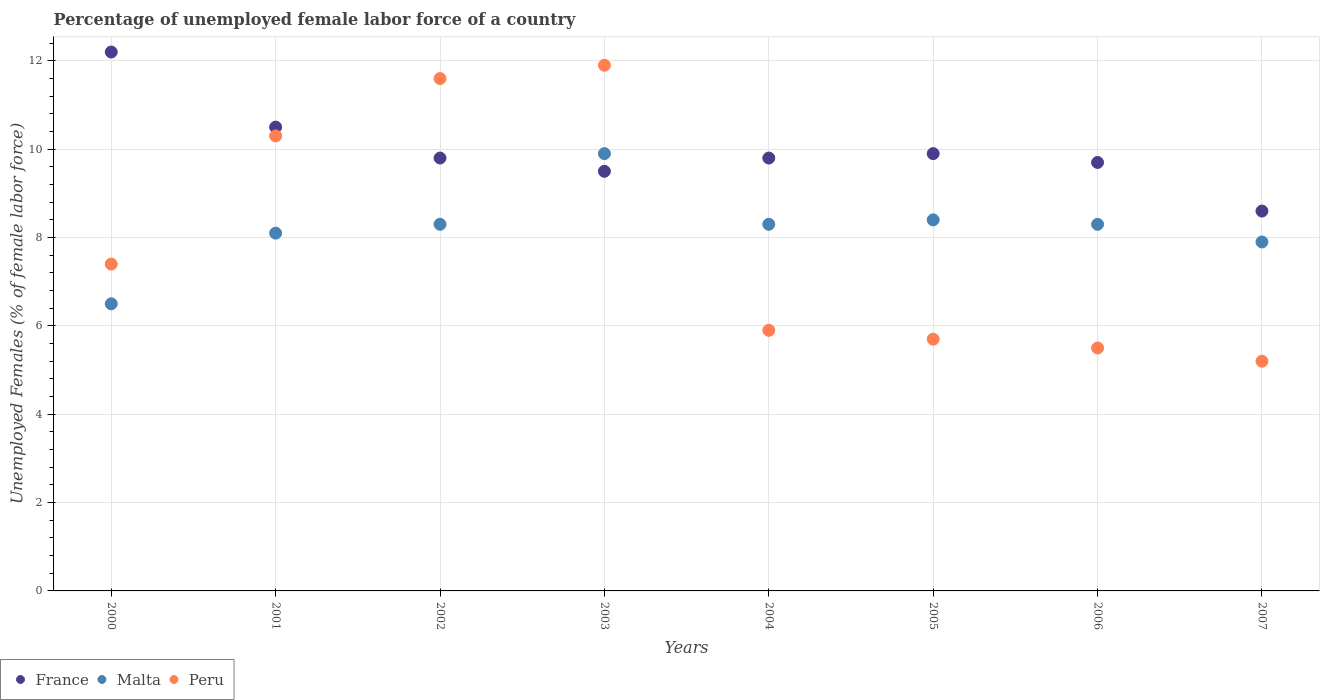What is the percentage of unemployed female labor force in Malta in 2004?
Your answer should be compact. 8.3. Across all years, what is the maximum percentage of unemployed female labor force in Peru?
Your answer should be very brief. 11.9. Across all years, what is the minimum percentage of unemployed female labor force in Peru?
Your answer should be compact. 5.2. What is the total percentage of unemployed female labor force in Malta in the graph?
Provide a short and direct response. 65.7. What is the difference between the percentage of unemployed female labor force in Peru in 2005 and that in 2007?
Your response must be concise. 0.5. What is the difference between the percentage of unemployed female labor force in France in 2005 and the percentage of unemployed female labor force in Malta in 2007?
Keep it short and to the point. 2. What is the average percentage of unemployed female labor force in France per year?
Give a very brief answer. 10. In the year 2007, what is the difference between the percentage of unemployed female labor force in Malta and percentage of unemployed female labor force in Peru?
Offer a terse response. 2.7. What is the ratio of the percentage of unemployed female labor force in Malta in 2003 to that in 2006?
Your answer should be compact. 1.19. Is the percentage of unemployed female labor force in Peru in 2000 less than that in 2003?
Ensure brevity in your answer.  Yes. Is the difference between the percentage of unemployed female labor force in Malta in 2001 and 2005 greater than the difference between the percentage of unemployed female labor force in Peru in 2001 and 2005?
Your response must be concise. No. What is the difference between the highest and the lowest percentage of unemployed female labor force in Malta?
Offer a terse response. 3.4. In how many years, is the percentage of unemployed female labor force in Peru greater than the average percentage of unemployed female labor force in Peru taken over all years?
Offer a terse response. 3. Does the percentage of unemployed female labor force in France monotonically increase over the years?
Offer a terse response. No. How many dotlines are there?
Your response must be concise. 3. Are the values on the major ticks of Y-axis written in scientific E-notation?
Provide a short and direct response. No. Does the graph contain any zero values?
Offer a terse response. No. What is the title of the graph?
Offer a terse response. Percentage of unemployed female labor force of a country. What is the label or title of the Y-axis?
Ensure brevity in your answer.  Unemployed Females (% of female labor force). What is the Unemployed Females (% of female labor force) in France in 2000?
Make the answer very short. 12.2. What is the Unemployed Females (% of female labor force) of Peru in 2000?
Offer a very short reply. 7.4. What is the Unemployed Females (% of female labor force) of France in 2001?
Give a very brief answer. 10.5. What is the Unemployed Females (% of female labor force) in Malta in 2001?
Provide a succinct answer. 8.1. What is the Unemployed Females (% of female labor force) in Peru in 2001?
Your response must be concise. 10.3. What is the Unemployed Females (% of female labor force) in France in 2002?
Ensure brevity in your answer.  9.8. What is the Unemployed Females (% of female labor force) in Malta in 2002?
Provide a short and direct response. 8.3. What is the Unemployed Females (% of female labor force) in Peru in 2002?
Your response must be concise. 11.6. What is the Unemployed Females (% of female labor force) in Malta in 2003?
Your response must be concise. 9.9. What is the Unemployed Females (% of female labor force) of Peru in 2003?
Offer a terse response. 11.9. What is the Unemployed Females (% of female labor force) in France in 2004?
Provide a short and direct response. 9.8. What is the Unemployed Females (% of female labor force) of Malta in 2004?
Ensure brevity in your answer.  8.3. What is the Unemployed Females (% of female labor force) of Peru in 2004?
Your answer should be very brief. 5.9. What is the Unemployed Females (% of female labor force) in France in 2005?
Offer a very short reply. 9.9. What is the Unemployed Females (% of female labor force) of Malta in 2005?
Give a very brief answer. 8.4. What is the Unemployed Females (% of female labor force) of Peru in 2005?
Provide a short and direct response. 5.7. What is the Unemployed Females (% of female labor force) in France in 2006?
Make the answer very short. 9.7. What is the Unemployed Females (% of female labor force) of Malta in 2006?
Make the answer very short. 8.3. What is the Unemployed Females (% of female labor force) in France in 2007?
Ensure brevity in your answer.  8.6. What is the Unemployed Females (% of female labor force) of Malta in 2007?
Provide a succinct answer. 7.9. What is the Unemployed Females (% of female labor force) in Peru in 2007?
Provide a short and direct response. 5.2. Across all years, what is the maximum Unemployed Females (% of female labor force) in France?
Your answer should be very brief. 12.2. Across all years, what is the maximum Unemployed Females (% of female labor force) in Malta?
Provide a short and direct response. 9.9. Across all years, what is the maximum Unemployed Females (% of female labor force) of Peru?
Provide a succinct answer. 11.9. Across all years, what is the minimum Unemployed Females (% of female labor force) in France?
Your answer should be very brief. 8.6. Across all years, what is the minimum Unemployed Females (% of female labor force) of Peru?
Your answer should be very brief. 5.2. What is the total Unemployed Females (% of female labor force) in Malta in the graph?
Ensure brevity in your answer.  65.7. What is the total Unemployed Females (% of female labor force) in Peru in the graph?
Provide a succinct answer. 63.5. What is the difference between the Unemployed Females (% of female labor force) of France in 2000 and that in 2001?
Keep it short and to the point. 1.7. What is the difference between the Unemployed Females (% of female labor force) of France in 2000 and that in 2002?
Ensure brevity in your answer.  2.4. What is the difference between the Unemployed Females (% of female labor force) in Malta in 2000 and that in 2002?
Give a very brief answer. -1.8. What is the difference between the Unemployed Females (% of female labor force) in Peru in 2000 and that in 2002?
Your answer should be very brief. -4.2. What is the difference between the Unemployed Females (% of female labor force) of France in 2000 and that in 2003?
Your answer should be very brief. 2.7. What is the difference between the Unemployed Females (% of female labor force) of Malta in 2000 and that in 2003?
Your response must be concise. -3.4. What is the difference between the Unemployed Females (% of female labor force) of Peru in 2000 and that in 2003?
Your answer should be compact. -4.5. What is the difference between the Unemployed Females (% of female labor force) in Peru in 2000 and that in 2004?
Offer a very short reply. 1.5. What is the difference between the Unemployed Females (% of female labor force) of Malta in 2000 and that in 2005?
Offer a very short reply. -1.9. What is the difference between the Unemployed Females (% of female labor force) of Peru in 2000 and that in 2005?
Make the answer very short. 1.7. What is the difference between the Unemployed Females (% of female labor force) of Malta in 2000 and that in 2006?
Keep it short and to the point. -1.8. What is the difference between the Unemployed Females (% of female labor force) in Peru in 2000 and that in 2006?
Make the answer very short. 1.9. What is the difference between the Unemployed Females (% of female labor force) in France in 2000 and that in 2007?
Your answer should be very brief. 3.6. What is the difference between the Unemployed Females (% of female labor force) in Malta in 2000 and that in 2007?
Ensure brevity in your answer.  -1.4. What is the difference between the Unemployed Females (% of female labor force) of Peru in 2000 and that in 2007?
Your answer should be compact. 2.2. What is the difference between the Unemployed Females (% of female labor force) in France in 2001 and that in 2002?
Provide a succinct answer. 0.7. What is the difference between the Unemployed Females (% of female labor force) of Malta in 2001 and that in 2002?
Make the answer very short. -0.2. What is the difference between the Unemployed Females (% of female labor force) of Peru in 2001 and that in 2002?
Your answer should be very brief. -1.3. What is the difference between the Unemployed Females (% of female labor force) of France in 2001 and that in 2003?
Make the answer very short. 1. What is the difference between the Unemployed Females (% of female labor force) in Malta in 2001 and that in 2003?
Your response must be concise. -1.8. What is the difference between the Unemployed Females (% of female labor force) of Malta in 2001 and that in 2004?
Provide a succinct answer. -0.2. What is the difference between the Unemployed Females (% of female labor force) of France in 2001 and that in 2005?
Your answer should be very brief. 0.6. What is the difference between the Unemployed Females (% of female labor force) of Malta in 2001 and that in 2006?
Your response must be concise. -0.2. What is the difference between the Unemployed Females (% of female labor force) of France in 2001 and that in 2007?
Your answer should be very brief. 1.9. What is the difference between the Unemployed Females (% of female labor force) in Peru in 2001 and that in 2007?
Offer a very short reply. 5.1. What is the difference between the Unemployed Females (% of female labor force) in France in 2002 and that in 2004?
Your response must be concise. 0. What is the difference between the Unemployed Females (% of female labor force) of Peru in 2002 and that in 2004?
Make the answer very short. 5.7. What is the difference between the Unemployed Females (% of female labor force) of France in 2002 and that in 2006?
Your answer should be compact. 0.1. What is the difference between the Unemployed Females (% of female labor force) in Malta in 2002 and that in 2006?
Your answer should be compact. 0. What is the difference between the Unemployed Females (% of female labor force) of Peru in 2002 and that in 2006?
Your answer should be compact. 6.1. What is the difference between the Unemployed Females (% of female labor force) of France in 2002 and that in 2007?
Offer a terse response. 1.2. What is the difference between the Unemployed Females (% of female labor force) in Peru in 2002 and that in 2007?
Your response must be concise. 6.4. What is the difference between the Unemployed Females (% of female labor force) of Malta in 2003 and that in 2004?
Your answer should be compact. 1.6. What is the difference between the Unemployed Females (% of female labor force) in France in 2003 and that in 2005?
Offer a very short reply. -0.4. What is the difference between the Unemployed Females (% of female labor force) of Malta in 2003 and that in 2005?
Make the answer very short. 1.5. What is the difference between the Unemployed Females (% of female labor force) of Malta in 2003 and that in 2006?
Ensure brevity in your answer.  1.6. What is the difference between the Unemployed Females (% of female labor force) in France in 2003 and that in 2007?
Keep it short and to the point. 0.9. What is the difference between the Unemployed Females (% of female labor force) of Malta in 2003 and that in 2007?
Give a very brief answer. 2. What is the difference between the Unemployed Females (% of female labor force) in France in 2004 and that in 2005?
Give a very brief answer. -0.1. What is the difference between the Unemployed Females (% of female labor force) in Malta in 2004 and that in 2005?
Offer a very short reply. -0.1. What is the difference between the Unemployed Females (% of female labor force) in Peru in 2004 and that in 2005?
Offer a very short reply. 0.2. What is the difference between the Unemployed Females (% of female labor force) in France in 2005 and that in 2006?
Ensure brevity in your answer.  0.2. What is the difference between the Unemployed Females (% of female labor force) in Malta in 2005 and that in 2007?
Offer a terse response. 0.5. What is the difference between the Unemployed Females (% of female labor force) of France in 2006 and that in 2007?
Provide a succinct answer. 1.1. What is the difference between the Unemployed Females (% of female labor force) of Malta in 2006 and that in 2007?
Ensure brevity in your answer.  0.4. What is the difference between the Unemployed Females (% of female labor force) in France in 2000 and the Unemployed Females (% of female labor force) in Peru in 2001?
Offer a very short reply. 1.9. What is the difference between the Unemployed Females (% of female labor force) of France in 2000 and the Unemployed Females (% of female labor force) of Malta in 2002?
Your answer should be very brief. 3.9. What is the difference between the Unemployed Females (% of female labor force) of France in 2000 and the Unemployed Females (% of female labor force) of Peru in 2002?
Offer a terse response. 0.6. What is the difference between the Unemployed Females (% of female labor force) in France in 2000 and the Unemployed Females (% of female labor force) in Malta in 2003?
Offer a very short reply. 2.3. What is the difference between the Unemployed Females (% of female labor force) of France in 2000 and the Unemployed Females (% of female labor force) of Malta in 2004?
Ensure brevity in your answer.  3.9. What is the difference between the Unemployed Females (% of female labor force) in France in 2000 and the Unemployed Females (% of female labor force) in Peru in 2005?
Make the answer very short. 6.5. What is the difference between the Unemployed Females (% of female labor force) of Malta in 2000 and the Unemployed Females (% of female labor force) of Peru in 2005?
Your answer should be very brief. 0.8. What is the difference between the Unemployed Females (% of female labor force) of France in 2000 and the Unemployed Females (% of female labor force) of Malta in 2006?
Your answer should be compact. 3.9. What is the difference between the Unemployed Females (% of female labor force) of Malta in 2000 and the Unemployed Females (% of female labor force) of Peru in 2006?
Offer a terse response. 1. What is the difference between the Unemployed Females (% of female labor force) in France in 2000 and the Unemployed Females (% of female labor force) in Peru in 2007?
Provide a succinct answer. 7. What is the difference between the Unemployed Females (% of female labor force) in Malta in 2000 and the Unemployed Females (% of female labor force) in Peru in 2007?
Your response must be concise. 1.3. What is the difference between the Unemployed Females (% of female labor force) of France in 2001 and the Unemployed Females (% of female labor force) of Peru in 2002?
Your response must be concise. -1.1. What is the difference between the Unemployed Females (% of female labor force) in France in 2001 and the Unemployed Females (% of female labor force) in Malta in 2003?
Offer a very short reply. 0.6. What is the difference between the Unemployed Females (% of female labor force) in France in 2001 and the Unemployed Females (% of female labor force) in Peru in 2003?
Your response must be concise. -1.4. What is the difference between the Unemployed Females (% of female labor force) in Malta in 2001 and the Unemployed Females (% of female labor force) in Peru in 2004?
Your answer should be compact. 2.2. What is the difference between the Unemployed Females (% of female labor force) in France in 2001 and the Unemployed Females (% of female labor force) in Peru in 2005?
Ensure brevity in your answer.  4.8. What is the difference between the Unemployed Females (% of female labor force) in France in 2001 and the Unemployed Females (% of female labor force) in Malta in 2006?
Provide a succinct answer. 2.2. What is the difference between the Unemployed Females (% of female labor force) in France in 2001 and the Unemployed Females (% of female labor force) in Malta in 2007?
Ensure brevity in your answer.  2.6. What is the difference between the Unemployed Females (% of female labor force) of France in 2001 and the Unemployed Females (% of female labor force) of Peru in 2007?
Your response must be concise. 5.3. What is the difference between the Unemployed Females (% of female labor force) of Malta in 2001 and the Unemployed Females (% of female labor force) of Peru in 2007?
Your answer should be compact. 2.9. What is the difference between the Unemployed Females (% of female labor force) in Malta in 2002 and the Unemployed Females (% of female labor force) in Peru in 2004?
Provide a short and direct response. 2.4. What is the difference between the Unemployed Females (% of female labor force) in Malta in 2002 and the Unemployed Females (% of female labor force) in Peru in 2005?
Make the answer very short. 2.6. What is the difference between the Unemployed Females (% of female labor force) of Malta in 2002 and the Unemployed Females (% of female labor force) of Peru in 2006?
Provide a succinct answer. 2.8. What is the difference between the Unemployed Females (% of female labor force) of France in 2003 and the Unemployed Females (% of female labor force) of Malta in 2004?
Provide a short and direct response. 1.2. What is the difference between the Unemployed Females (% of female labor force) of France in 2003 and the Unemployed Females (% of female labor force) of Peru in 2005?
Your response must be concise. 3.8. What is the difference between the Unemployed Females (% of female labor force) in Malta in 2003 and the Unemployed Females (% of female labor force) in Peru in 2005?
Offer a very short reply. 4.2. What is the difference between the Unemployed Females (% of female labor force) in France in 2003 and the Unemployed Females (% of female labor force) in Malta in 2006?
Ensure brevity in your answer.  1.2. What is the difference between the Unemployed Females (% of female labor force) of France in 2003 and the Unemployed Females (% of female labor force) of Peru in 2006?
Give a very brief answer. 4. What is the difference between the Unemployed Females (% of female labor force) of Malta in 2003 and the Unemployed Females (% of female labor force) of Peru in 2006?
Your response must be concise. 4.4. What is the difference between the Unemployed Females (% of female labor force) of France in 2003 and the Unemployed Females (% of female labor force) of Peru in 2007?
Give a very brief answer. 4.3. What is the difference between the Unemployed Females (% of female labor force) in France in 2004 and the Unemployed Females (% of female labor force) in Malta in 2005?
Give a very brief answer. 1.4. What is the difference between the Unemployed Females (% of female labor force) of France in 2004 and the Unemployed Females (% of female labor force) of Peru in 2006?
Your answer should be compact. 4.3. What is the difference between the Unemployed Females (% of female labor force) of Malta in 2004 and the Unemployed Females (% of female labor force) of Peru in 2006?
Your answer should be compact. 2.8. What is the difference between the Unemployed Females (% of female labor force) in France in 2004 and the Unemployed Females (% of female labor force) in Malta in 2007?
Provide a succinct answer. 1.9. What is the difference between the Unemployed Females (% of female labor force) in France in 2004 and the Unemployed Females (% of female labor force) in Peru in 2007?
Offer a terse response. 4.6. What is the difference between the Unemployed Females (% of female labor force) of France in 2006 and the Unemployed Females (% of female labor force) of Malta in 2007?
Provide a short and direct response. 1.8. What is the average Unemployed Females (% of female labor force) in France per year?
Offer a very short reply. 10. What is the average Unemployed Females (% of female labor force) in Malta per year?
Your response must be concise. 8.21. What is the average Unemployed Females (% of female labor force) in Peru per year?
Your response must be concise. 7.94. In the year 2000, what is the difference between the Unemployed Females (% of female labor force) in Malta and Unemployed Females (% of female labor force) in Peru?
Keep it short and to the point. -0.9. In the year 2001, what is the difference between the Unemployed Females (% of female labor force) of France and Unemployed Females (% of female labor force) of Peru?
Offer a terse response. 0.2. In the year 2001, what is the difference between the Unemployed Females (% of female labor force) in Malta and Unemployed Females (% of female labor force) in Peru?
Provide a short and direct response. -2.2. In the year 2002, what is the difference between the Unemployed Females (% of female labor force) in France and Unemployed Females (% of female labor force) in Malta?
Give a very brief answer. 1.5. In the year 2002, what is the difference between the Unemployed Females (% of female labor force) in France and Unemployed Females (% of female labor force) in Peru?
Make the answer very short. -1.8. In the year 2003, what is the difference between the Unemployed Females (% of female labor force) of France and Unemployed Females (% of female labor force) of Peru?
Ensure brevity in your answer.  -2.4. In the year 2004, what is the difference between the Unemployed Females (% of female labor force) in France and Unemployed Females (% of female labor force) in Malta?
Your answer should be compact. 1.5. In the year 2004, what is the difference between the Unemployed Females (% of female labor force) in France and Unemployed Females (% of female labor force) in Peru?
Your answer should be very brief. 3.9. In the year 2005, what is the difference between the Unemployed Females (% of female labor force) of France and Unemployed Females (% of female labor force) of Malta?
Provide a succinct answer. 1.5. In the year 2006, what is the difference between the Unemployed Females (% of female labor force) in France and Unemployed Females (% of female labor force) in Malta?
Your answer should be very brief. 1.4. In the year 2006, what is the difference between the Unemployed Females (% of female labor force) in Malta and Unemployed Females (% of female labor force) in Peru?
Ensure brevity in your answer.  2.8. In the year 2007, what is the difference between the Unemployed Females (% of female labor force) of Malta and Unemployed Females (% of female labor force) of Peru?
Make the answer very short. 2.7. What is the ratio of the Unemployed Females (% of female labor force) in France in 2000 to that in 2001?
Offer a terse response. 1.16. What is the ratio of the Unemployed Females (% of female labor force) of Malta in 2000 to that in 2001?
Your answer should be compact. 0.8. What is the ratio of the Unemployed Females (% of female labor force) in Peru in 2000 to that in 2001?
Your answer should be compact. 0.72. What is the ratio of the Unemployed Females (% of female labor force) of France in 2000 to that in 2002?
Give a very brief answer. 1.24. What is the ratio of the Unemployed Females (% of female labor force) of Malta in 2000 to that in 2002?
Give a very brief answer. 0.78. What is the ratio of the Unemployed Females (% of female labor force) of Peru in 2000 to that in 2002?
Your response must be concise. 0.64. What is the ratio of the Unemployed Females (% of female labor force) in France in 2000 to that in 2003?
Provide a succinct answer. 1.28. What is the ratio of the Unemployed Females (% of female labor force) in Malta in 2000 to that in 2003?
Provide a succinct answer. 0.66. What is the ratio of the Unemployed Females (% of female labor force) of Peru in 2000 to that in 2003?
Keep it short and to the point. 0.62. What is the ratio of the Unemployed Females (% of female labor force) of France in 2000 to that in 2004?
Ensure brevity in your answer.  1.24. What is the ratio of the Unemployed Females (% of female labor force) of Malta in 2000 to that in 2004?
Give a very brief answer. 0.78. What is the ratio of the Unemployed Females (% of female labor force) in Peru in 2000 to that in 2004?
Offer a very short reply. 1.25. What is the ratio of the Unemployed Females (% of female labor force) in France in 2000 to that in 2005?
Provide a succinct answer. 1.23. What is the ratio of the Unemployed Females (% of female labor force) of Malta in 2000 to that in 2005?
Make the answer very short. 0.77. What is the ratio of the Unemployed Females (% of female labor force) of Peru in 2000 to that in 2005?
Your response must be concise. 1.3. What is the ratio of the Unemployed Females (% of female labor force) in France in 2000 to that in 2006?
Make the answer very short. 1.26. What is the ratio of the Unemployed Females (% of female labor force) of Malta in 2000 to that in 2006?
Keep it short and to the point. 0.78. What is the ratio of the Unemployed Females (% of female labor force) in Peru in 2000 to that in 2006?
Keep it short and to the point. 1.35. What is the ratio of the Unemployed Females (% of female labor force) in France in 2000 to that in 2007?
Provide a succinct answer. 1.42. What is the ratio of the Unemployed Females (% of female labor force) of Malta in 2000 to that in 2007?
Keep it short and to the point. 0.82. What is the ratio of the Unemployed Females (% of female labor force) of Peru in 2000 to that in 2007?
Provide a succinct answer. 1.42. What is the ratio of the Unemployed Females (% of female labor force) of France in 2001 to that in 2002?
Provide a short and direct response. 1.07. What is the ratio of the Unemployed Females (% of female labor force) of Malta in 2001 to that in 2002?
Keep it short and to the point. 0.98. What is the ratio of the Unemployed Females (% of female labor force) of Peru in 2001 to that in 2002?
Offer a very short reply. 0.89. What is the ratio of the Unemployed Females (% of female labor force) in France in 2001 to that in 2003?
Your response must be concise. 1.11. What is the ratio of the Unemployed Females (% of female labor force) of Malta in 2001 to that in 2003?
Your answer should be compact. 0.82. What is the ratio of the Unemployed Females (% of female labor force) in Peru in 2001 to that in 2003?
Your answer should be very brief. 0.87. What is the ratio of the Unemployed Females (% of female labor force) of France in 2001 to that in 2004?
Your response must be concise. 1.07. What is the ratio of the Unemployed Females (% of female labor force) of Malta in 2001 to that in 2004?
Your response must be concise. 0.98. What is the ratio of the Unemployed Females (% of female labor force) in Peru in 2001 to that in 2004?
Your answer should be very brief. 1.75. What is the ratio of the Unemployed Females (% of female labor force) of France in 2001 to that in 2005?
Provide a succinct answer. 1.06. What is the ratio of the Unemployed Females (% of female labor force) in Malta in 2001 to that in 2005?
Ensure brevity in your answer.  0.96. What is the ratio of the Unemployed Females (% of female labor force) in Peru in 2001 to that in 2005?
Make the answer very short. 1.81. What is the ratio of the Unemployed Females (% of female labor force) of France in 2001 to that in 2006?
Provide a short and direct response. 1.08. What is the ratio of the Unemployed Females (% of female labor force) of Malta in 2001 to that in 2006?
Your answer should be compact. 0.98. What is the ratio of the Unemployed Females (% of female labor force) of Peru in 2001 to that in 2006?
Provide a short and direct response. 1.87. What is the ratio of the Unemployed Females (% of female labor force) of France in 2001 to that in 2007?
Ensure brevity in your answer.  1.22. What is the ratio of the Unemployed Females (% of female labor force) in Malta in 2001 to that in 2007?
Provide a succinct answer. 1.03. What is the ratio of the Unemployed Females (% of female labor force) in Peru in 2001 to that in 2007?
Offer a terse response. 1.98. What is the ratio of the Unemployed Females (% of female labor force) of France in 2002 to that in 2003?
Provide a succinct answer. 1.03. What is the ratio of the Unemployed Females (% of female labor force) in Malta in 2002 to that in 2003?
Offer a terse response. 0.84. What is the ratio of the Unemployed Females (% of female labor force) of Peru in 2002 to that in 2003?
Provide a short and direct response. 0.97. What is the ratio of the Unemployed Females (% of female labor force) of France in 2002 to that in 2004?
Offer a very short reply. 1. What is the ratio of the Unemployed Females (% of female labor force) of Peru in 2002 to that in 2004?
Your answer should be compact. 1.97. What is the ratio of the Unemployed Females (% of female labor force) in France in 2002 to that in 2005?
Make the answer very short. 0.99. What is the ratio of the Unemployed Females (% of female labor force) of Malta in 2002 to that in 2005?
Your answer should be compact. 0.99. What is the ratio of the Unemployed Females (% of female labor force) in Peru in 2002 to that in 2005?
Offer a very short reply. 2.04. What is the ratio of the Unemployed Females (% of female labor force) in France in 2002 to that in 2006?
Ensure brevity in your answer.  1.01. What is the ratio of the Unemployed Females (% of female labor force) in Malta in 2002 to that in 2006?
Make the answer very short. 1. What is the ratio of the Unemployed Females (% of female labor force) in Peru in 2002 to that in 2006?
Provide a succinct answer. 2.11. What is the ratio of the Unemployed Females (% of female labor force) of France in 2002 to that in 2007?
Give a very brief answer. 1.14. What is the ratio of the Unemployed Females (% of female labor force) of Malta in 2002 to that in 2007?
Your answer should be compact. 1.05. What is the ratio of the Unemployed Females (% of female labor force) in Peru in 2002 to that in 2007?
Your answer should be very brief. 2.23. What is the ratio of the Unemployed Females (% of female labor force) of France in 2003 to that in 2004?
Ensure brevity in your answer.  0.97. What is the ratio of the Unemployed Females (% of female labor force) in Malta in 2003 to that in 2004?
Make the answer very short. 1.19. What is the ratio of the Unemployed Females (% of female labor force) of Peru in 2003 to that in 2004?
Provide a succinct answer. 2.02. What is the ratio of the Unemployed Females (% of female labor force) in France in 2003 to that in 2005?
Your answer should be very brief. 0.96. What is the ratio of the Unemployed Females (% of female labor force) in Malta in 2003 to that in 2005?
Offer a very short reply. 1.18. What is the ratio of the Unemployed Females (% of female labor force) of Peru in 2003 to that in 2005?
Your answer should be compact. 2.09. What is the ratio of the Unemployed Females (% of female labor force) in France in 2003 to that in 2006?
Your response must be concise. 0.98. What is the ratio of the Unemployed Females (% of female labor force) of Malta in 2003 to that in 2006?
Your response must be concise. 1.19. What is the ratio of the Unemployed Females (% of female labor force) of Peru in 2003 to that in 2006?
Offer a very short reply. 2.16. What is the ratio of the Unemployed Females (% of female labor force) in France in 2003 to that in 2007?
Your answer should be very brief. 1.1. What is the ratio of the Unemployed Females (% of female labor force) in Malta in 2003 to that in 2007?
Keep it short and to the point. 1.25. What is the ratio of the Unemployed Females (% of female labor force) of Peru in 2003 to that in 2007?
Provide a short and direct response. 2.29. What is the ratio of the Unemployed Females (% of female labor force) in Peru in 2004 to that in 2005?
Offer a very short reply. 1.04. What is the ratio of the Unemployed Females (% of female labor force) in France in 2004 to that in 2006?
Provide a short and direct response. 1.01. What is the ratio of the Unemployed Females (% of female labor force) in Malta in 2004 to that in 2006?
Provide a short and direct response. 1. What is the ratio of the Unemployed Females (% of female labor force) of Peru in 2004 to that in 2006?
Provide a short and direct response. 1.07. What is the ratio of the Unemployed Females (% of female labor force) in France in 2004 to that in 2007?
Keep it short and to the point. 1.14. What is the ratio of the Unemployed Females (% of female labor force) of Malta in 2004 to that in 2007?
Provide a short and direct response. 1.05. What is the ratio of the Unemployed Females (% of female labor force) in Peru in 2004 to that in 2007?
Provide a short and direct response. 1.13. What is the ratio of the Unemployed Females (% of female labor force) of France in 2005 to that in 2006?
Make the answer very short. 1.02. What is the ratio of the Unemployed Females (% of female labor force) of Malta in 2005 to that in 2006?
Provide a succinct answer. 1.01. What is the ratio of the Unemployed Females (% of female labor force) of Peru in 2005 to that in 2006?
Keep it short and to the point. 1.04. What is the ratio of the Unemployed Females (% of female labor force) of France in 2005 to that in 2007?
Offer a terse response. 1.15. What is the ratio of the Unemployed Females (% of female labor force) of Malta in 2005 to that in 2007?
Your answer should be very brief. 1.06. What is the ratio of the Unemployed Females (% of female labor force) of Peru in 2005 to that in 2007?
Your answer should be compact. 1.1. What is the ratio of the Unemployed Females (% of female labor force) in France in 2006 to that in 2007?
Your answer should be very brief. 1.13. What is the ratio of the Unemployed Females (% of female labor force) in Malta in 2006 to that in 2007?
Give a very brief answer. 1.05. What is the ratio of the Unemployed Females (% of female labor force) of Peru in 2006 to that in 2007?
Your answer should be compact. 1.06. What is the difference between the highest and the second highest Unemployed Females (% of female labor force) in France?
Offer a terse response. 1.7. What is the difference between the highest and the second highest Unemployed Females (% of female labor force) of Malta?
Provide a succinct answer. 1.5. What is the difference between the highest and the lowest Unemployed Females (% of female labor force) in Malta?
Your answer should be compact. 3.4. What is the difference between the highest and the lowest Unemployed Females (% of female labor force) of Peru?
Provide a succinct answer. 6.7. 